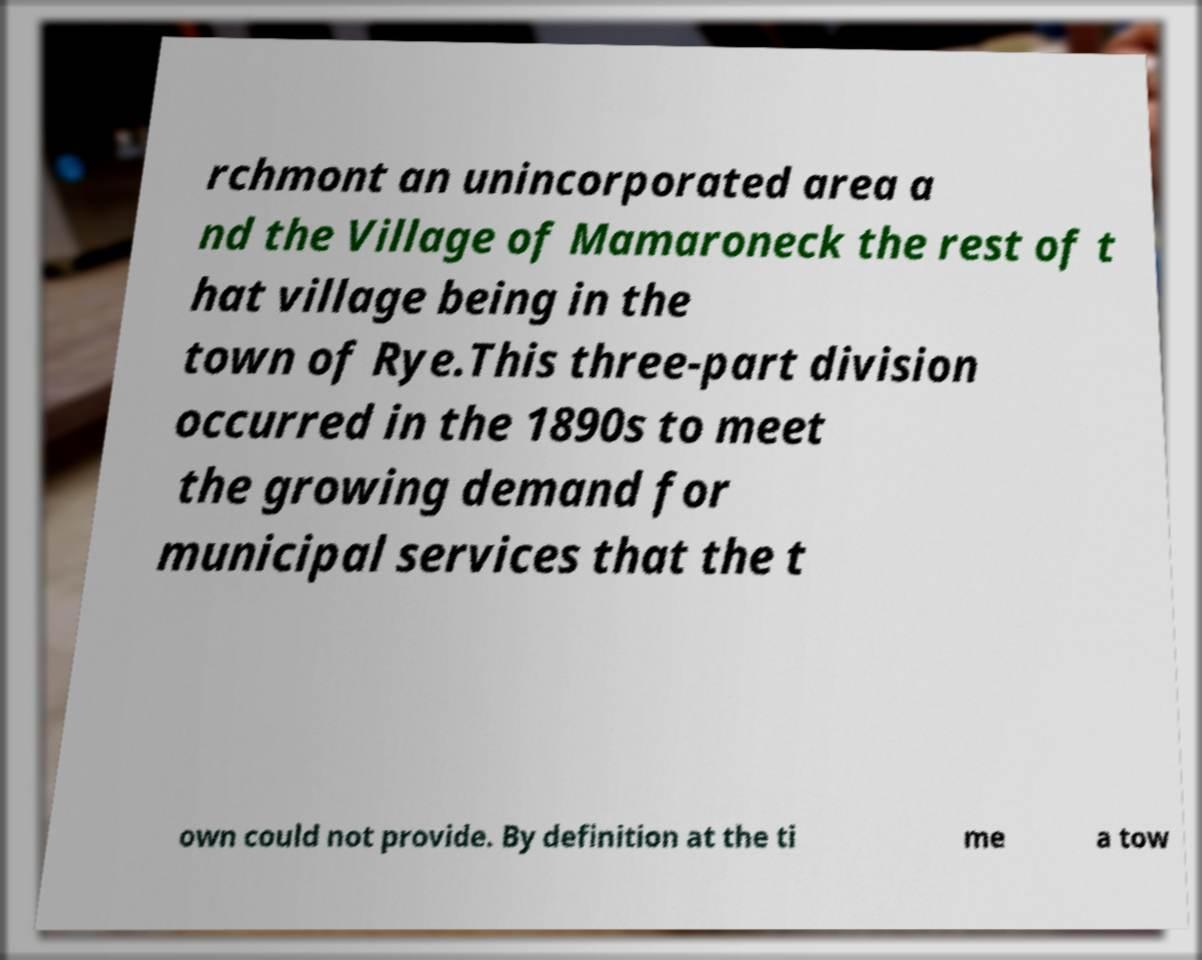Please read and relay the text visible in this image. What does it say? rchmont an unincorporated area a nd the Village of Mamaroneck the rest of t hat village being in the town of Rye.This three-part division occurred in the 1890s to meet the growing demand for municipal services that the t own could not provide. By definition at the ti me a tow 